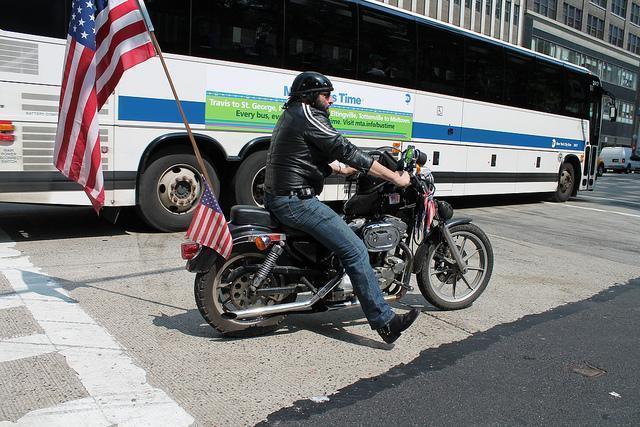Which one of these terms could be used to describe the motorcycle rider?
Answer the question by selecting the correct answer among the 4 following choices.
Options: Patriotic, traitor, apolitical, anarchist. Patriotic. 